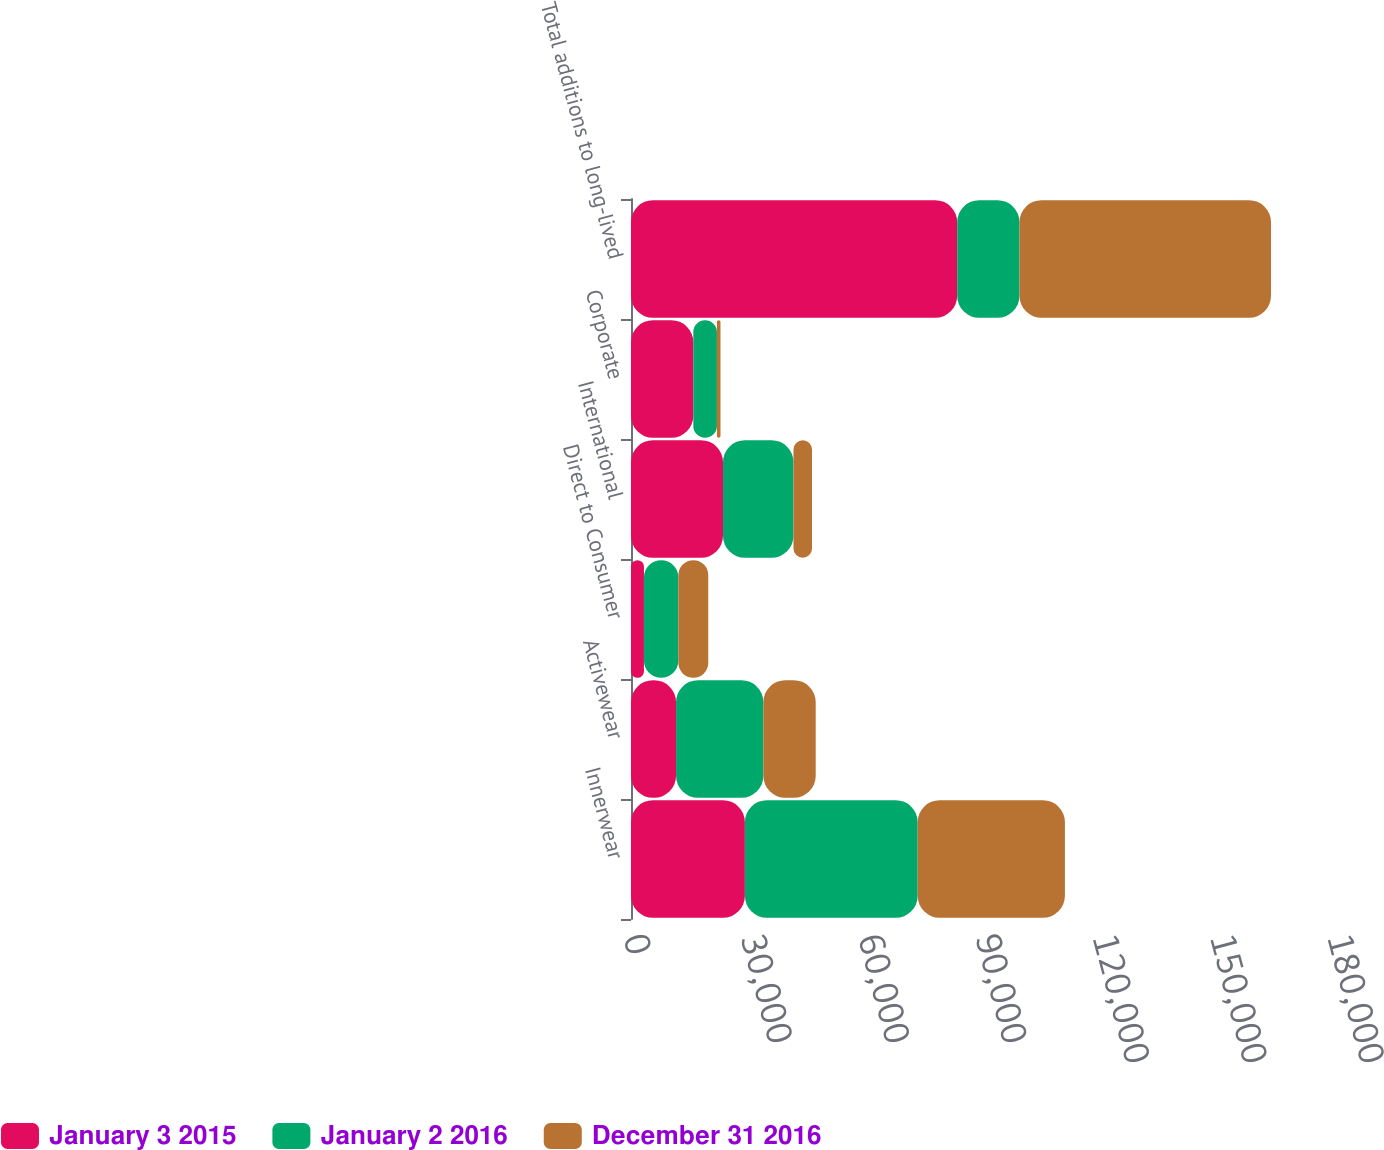Convert chart. <chart><loc_0><loc_0><loc_500><loc_500><stacked_bar_chart><ecel><fcel>Innerwear<fcel>Activewear<fcel>Direct to Consumer<fcel>International<fcel>Corporate<fcel>Total additions to long-lived<nl><fcel>January 3 2015<fcel>29119<fcel>11518<fcel>3312<fcel>23520<fcel>15930<fcel>83399<nl><fcel>January 2 2016<fcel>44183<fcel>22331<fcel>8802<fcel>18022<fcel>6037<fcel>15930<nl><fcel>December 31 2016<fcel>37641<fcel>13378<fcel>7641<fcel>4737<fcel>914<fcel>64311<nl></chart> 